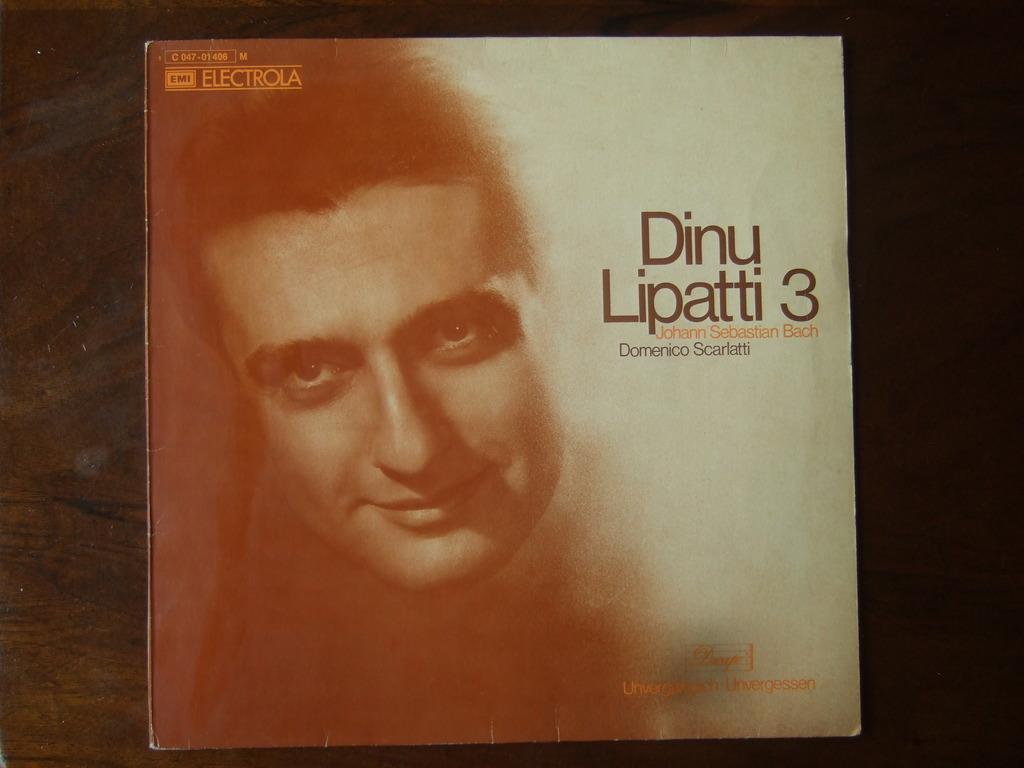Please provide a concise description of this image. In this picture we can see book cover on an object. On the book cover, there are words and an image of a person´s face. 